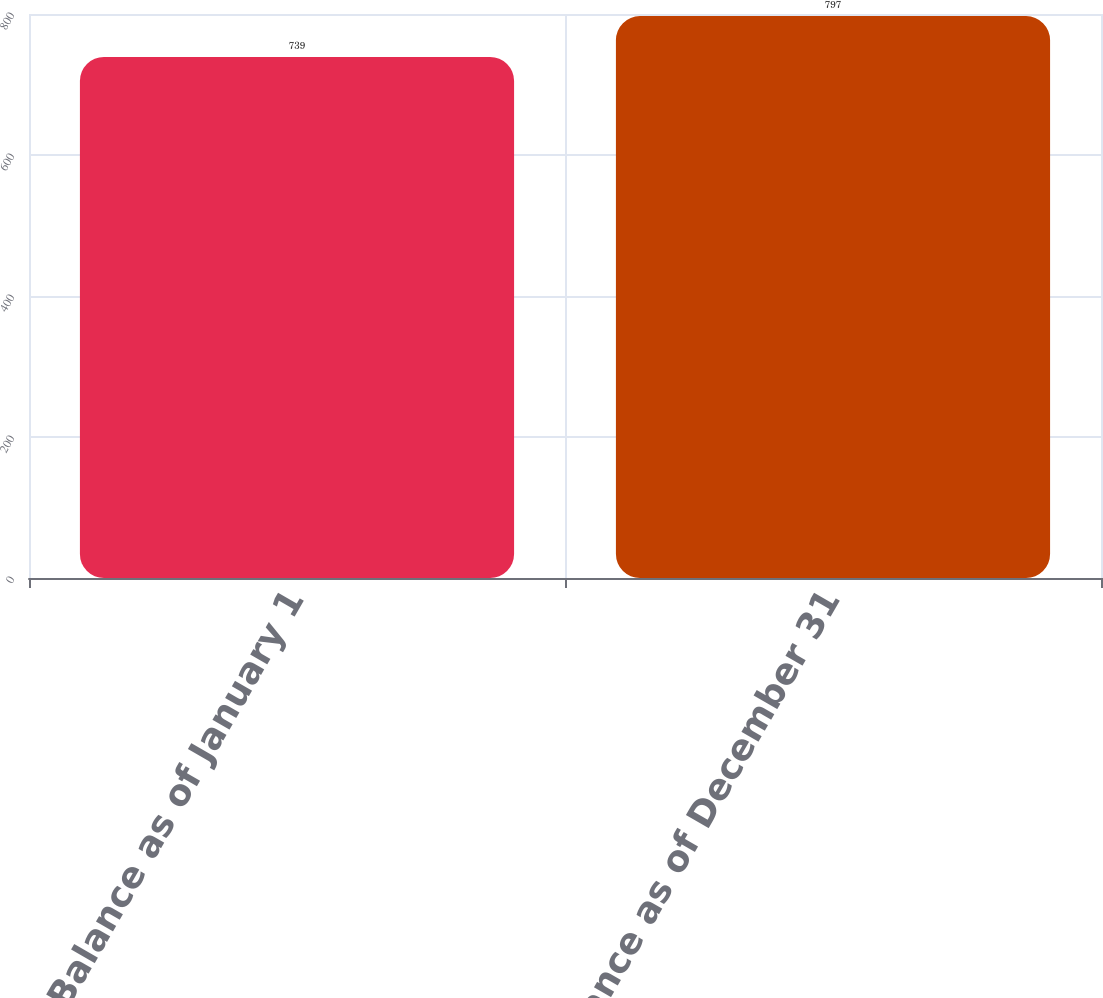Convert chart to OTSL. <chart><loc_0><loc_0><loc_500><loc_500><bar_chart><fcel>Balance as of January 1<fcel>Balance as of December 31<nl><fcel>739<fcel>797<nl></chart> 